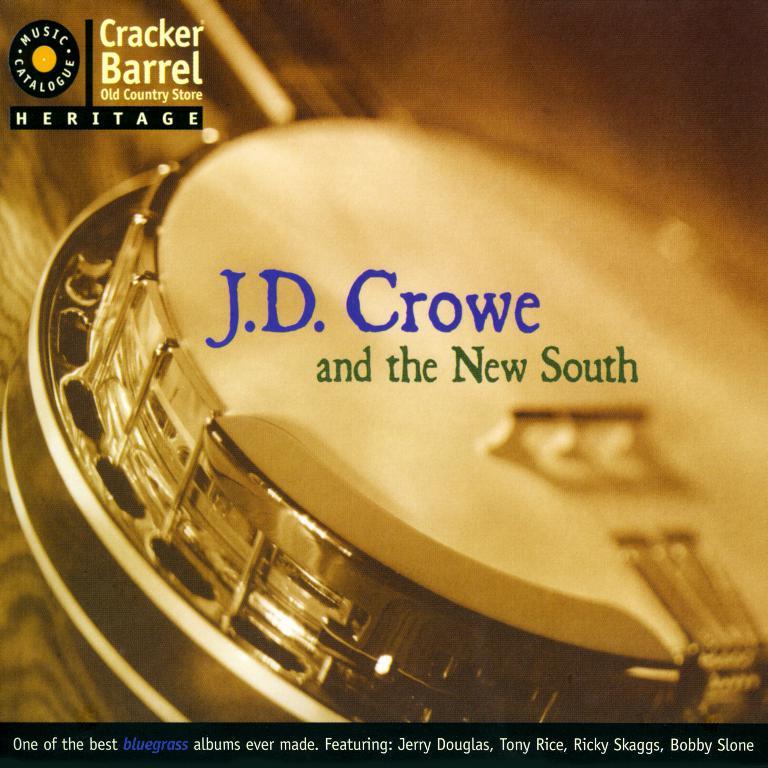What store is this for?
Make the answer very short. Cracker barrel. What is the band called?
Your response must be concise. J.d. crowe and the new south. 